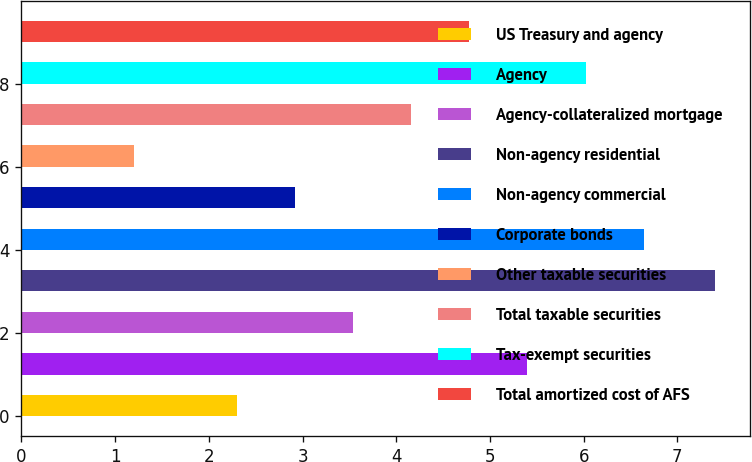<chart> <loc_0><loc_0><loc_500><loc_500><bar_chart><fcel>US Treasury and agency<fcel>Agency<fcel>Agency-collateralized mortgage<fcel>Non-agency residential<fcel>Non-agency commercial<fcel>Corporate bonds<fcel>Other taxable securities<fcel>Total taxable securities<fcel>Tax-exempt securities<fcel>Total amortized cost of AFS<nl><fcel>2.3<fcel>5.4<fcel>3.54<fcel>7.4<fcel>6.64<fcel>2.92<fcel>1.2<fcel>4.16<fcel>6.02<fcel>4.78<nl></chart> 